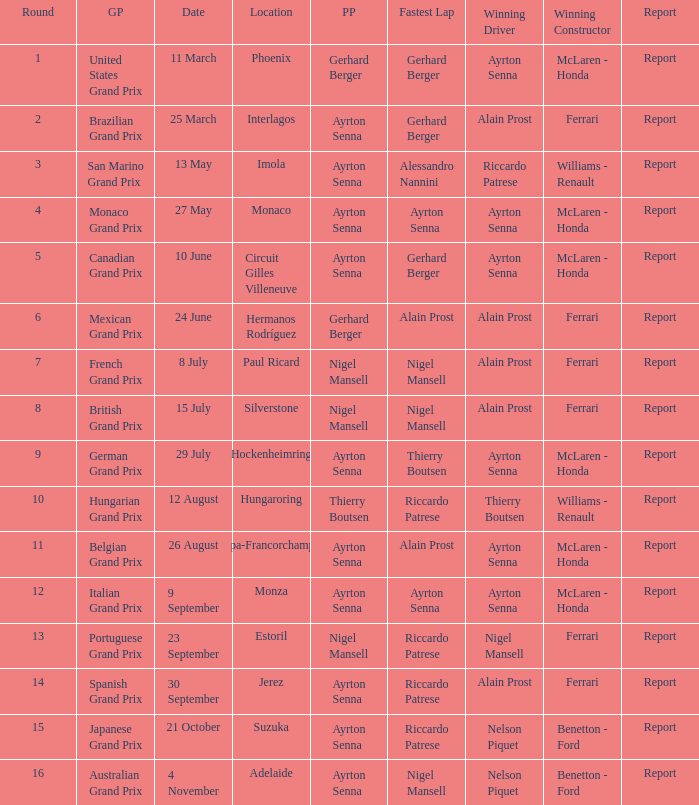What is the Pole Position for the German Grand Prix Ayrton Senna. Would you be able to parse every entry in this table? {'header': ['Round', 'GP', 'Date', 'Location', 'PP', 'Fastest Lap', 'Winning Driver', 'Winning Constructor', 'Report'], 'rows': [['1', 'United States Grand Prix', '11 March', 'Phoenix', 'Gerhard Berger', 'Gerhard Berger', 'Ayrton Senna', 'McLaren - Honda', 'Report'], ['2', 'Brazilian Grand Prix', '25 March', 'Interlagos', 'Ayrton Senna', 'Gerhard Berger', 'Alain Prost', 'Ferrari', 'Report'], ['3', 'San Marino Grand Prix', '13 May', 'Imola', 'Ayrton Senna', 'Alessandro Nannini', 'Riccardo Patrese', 'Williams - Renault', 'Report'], ['4', 'Monaco Grand Prix', '27 May', 'Monaco', 'Ayrton Senna', 'Ayrton Senna', 'Ayrton Senna', 'McLaren - Honda', 'Report'], ['5', 'Canadian Grand Prix', '10 June', 'Circuit Gilles Villeneuve', 'Ayrton Senna', 'Gerhard Berger', 'Ayrton Senna', 'McLaren - Honda', 'Report'], ['6', 'Mexican Grand Prix', '24 June', 'Hermanos Rodríguez', 'Gerhard Berger', 'Alain Prost', 'Alain Prost', 'Ferrari', 'Report'], ['7', 'French Grand Prix', '8 July', 'Paul Ricard', 'Nigel Mansell', 'Nigel Mansell', 'Alain Prost', 'Ferrari', 'Report'], ['8', 'British Grand Prix', '15 July', 'Silverstone', 'Nigel Mansell', 'Nigel Mansell', 'Alain Prost', 'Ferrari', 'Report'], ['9', 'German Grand Prix', '29 July', 'Hockenheimring', 'Ayrton Senna', 'Thierry Boutsen', 'Ayrton Senna', 'McLaren - Honda', 'Report'], ['10', 'Hungarian Grand Prix', '12 August', 'Hungaroring', 'Thierry Boutsen', 'Riccardo Patrese', 'Thierry Boutsen', 'Williams - Renault', 'Report'], ['11', 'Belgian Grand Prix', '26 August', 'Spa-Francorchamps', 'Ayrton Senna', 'Alain Prost', 'Ayrton Senna', 'McLaren - Honda', 'Report'], ['12', 'Italian Grand Prix', '9 September', 'Monza', 'Ayrton Senna', 'Ayrton Senna', 'Ayrton Senna', 'McLaren - Honda', 'Report'], ['13', 'Portuguese Grand Prix', '23 September', 'Estoril', 'Nigel Mansell', 'Riccardo Patrese', 'Nigel Mansell', 'Ferrari', 'Report'], ['14', 'Spanish Grand Prix', '30 September', 'Jerez', 'Ayrton Senna', 'Riccardo Patrese', 'Alain Prost', 'Ferrari', 'Report'], ['15', 'Japanese Grand Prix', '21 October', 'Suzuka', 'Ayrton Senna', 'Riccardo Patrese', 'Nelson Piquet', 'Benetton - Ford', 'Report'], ['16', 'Australian Grand Prix', '4 November', 'Adelaide', 'Ayrton Senna', 'Nigel Mansell', 'Nelson Piquet', 'Benetton - Ford', 'Report']]} 